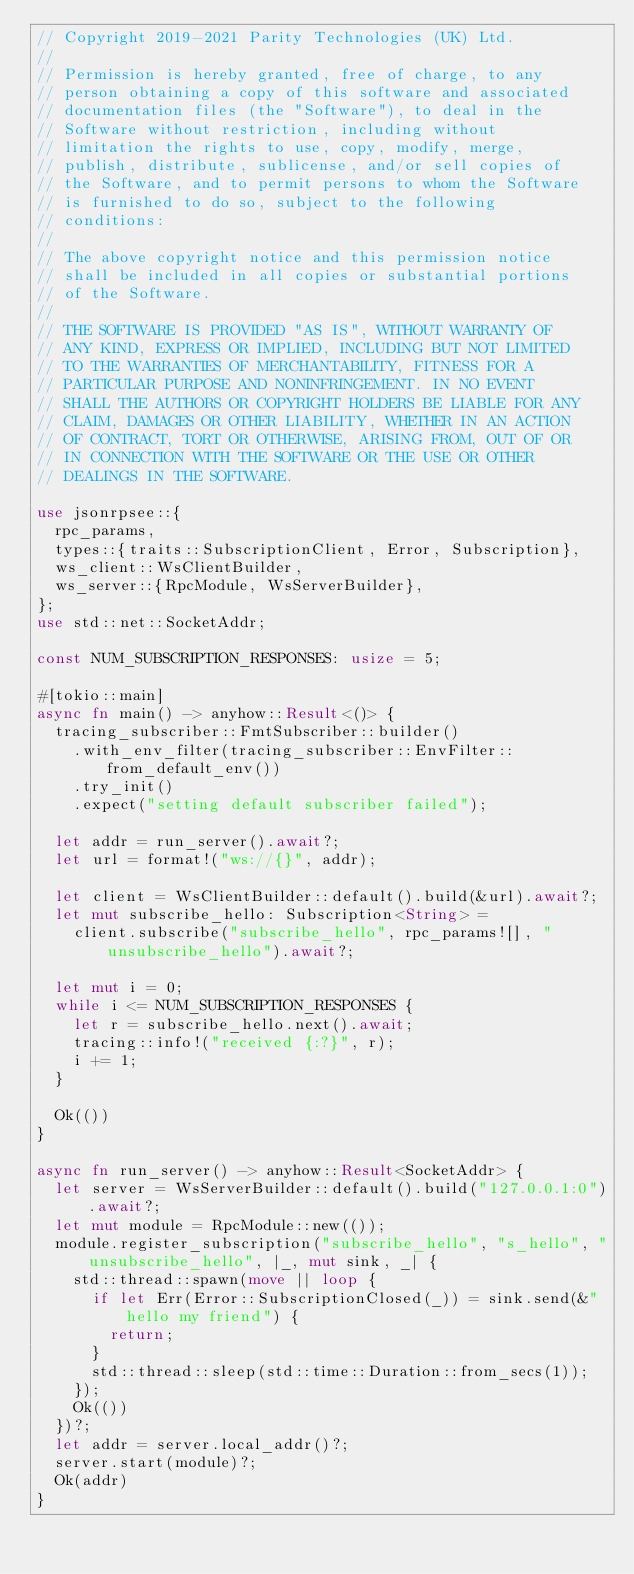Convert code to text. <code><loc_0><loc_0><loc_500><loc_500><_Rust_>// Copyright 2019-2021 Parity Technologies (UK) Ltd.
//
// Permission is hereby granted, free of charge, to any
// person obtaining a copy of this software and associated
// documentation files (the "Software"), to deal in the
// Software without restriction, including without
// limitation the rights to use, copy, modify, merge,
// publish, distribute, sublicense, and/or sell copies of
// the Software, and to permit persons to whom the Software
// is furnished to do so, subject to the following
// conditions:
//
// The above copyright notice and this permission notice
// shall be included in all copies or substantial portions
// of the Software.
//
// THE SOFTWARE IS PROVIDED "AS IS", WITHOUT WARRANTY OF
// ANY KIND, EXPRESS OR IMPLIED, INCLUDING BUT NOT LIMITED
// TO THE WARRANTIES OF MERCHANTABILITY, FITNESS FOR A
// PARTICULAR PURPOSE AND NONINFRINGEMENT. IN NO EVENT
// SHALL THE AUTHORS OR COPYRIGHT HOLDERS BE LIABLE FOR ANY
// CLAIM, DAMAGES OR OTHER LIABILITY, WHETHER IN AN ACTION
// OF CONTRACT, TORT OR OTHERWISE, ARISING FROM, OUT OF OR
// IN CONNECTION WITH THE SOFTWARE OR THE USE OR OTHER
// DEALINGS IN THE SOFTWARE.

use jsonrpsee::{
	rpc_params,
	types::{traits::SubscriptionClient, Error, Subscription},
	ws_client::WsClientBuilder,
	ws_server::{RpcModule, WsServerBuilder},
};
use std::net::SocketAddr;

const NUM_SUBSCRIPTION_RESPONSES: usize = 5;

#[tokio::main]
async fn main() -> anyhow::Result<()> {
	tracing_subscriber::FmtSubscriber::builder()
		.with_env_filter(tracing_subscriber::EnvFilter::from_default_env())
		.try_init()
		.expect("setting default subscriber failed");

	let addr = run_server().await?;
	let url = format!("ws://{}", addr);

	let client = WsClientBuilder::default().build(&url).await?;
	let mut subscribe_hello: Subscription<String> =
		client.subscribe("subscribe_hello", rpc_params![], "unsubscribe_hello").await?;

	let mut i = 0;
	while i <= NUM_SUBSCRIPTION_RESPONSES {
		let r = subscribe_hello.next().await;
		tracing::info!("received {:?}", r);
		i += 1;
	}

	Ok(())
}

async fn run_server() -> anyhow::Result<SocketAddr> {
	let server = WsServerBuilder::default().build("127.0.0.1:0").await?;
	let mut module = RpcModule::new(());
	module.register_subscription("subscribe_hello", "s_hello", "unsubscribe_hello", |_, mut sink, _| {
		std::thread::spawn(move || loop {
			if let Err(Error::SubscriptionClosed(_)) = sink.send(&"hello my friend") {
				return;
			}
			std::thread::sleep(std::time::Duration::from_secs(1));
		});
		Ok(())
	})?;
	let addr = server.local_addr()?;
	server.start(module)?;
	Ok(addr)
}
</code> 